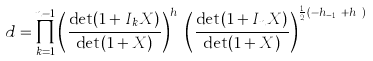<formula> <loc_0><loc_0><loc_500><loc_500>d = \prod _ { k = 1 } ^ { n - 1 } \left ( \frac { \det ( 1 + I _ { k } X ) } { \det ( 1 + X ) } \right ) ^ { h _ { k } } \left ( \frac { \det ( 1 + I _ { n } X ) } { \det ( 1 + X ) } \right ) ^ { \frac { 1 } { 2 } ( - h _ { n - 1 } + h _ { n } ) }</formula> 